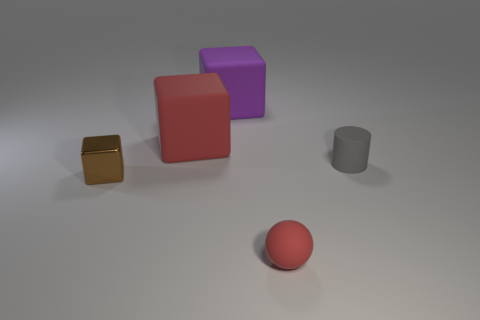How do the objects appear to be arranged? The objects are arranged with an emphasis on balance and simplicity, with enough space between them to prevent the scene from feeling cluttered, creating a sense of order and tranquility. 